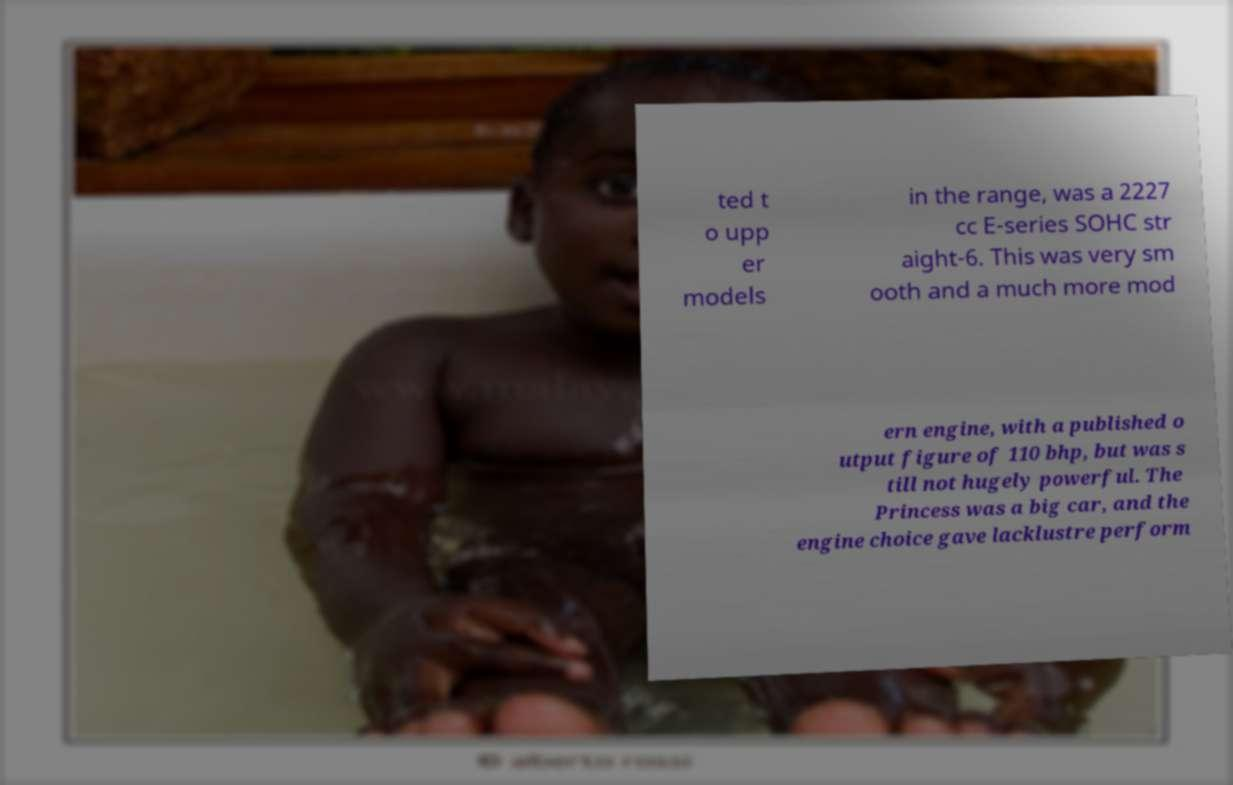Please read and relay the text visible in this image. What does it say? ted t o upp er models in the range, was a 2227 cc E-series SOHC str aight-6. This was very sm ooth and a much more mod ern engine, with a published o utput figure of 110 bhp, but was s till not hugely powerful. The Princess was a big car, and the engine choice gave lacklustre perform 